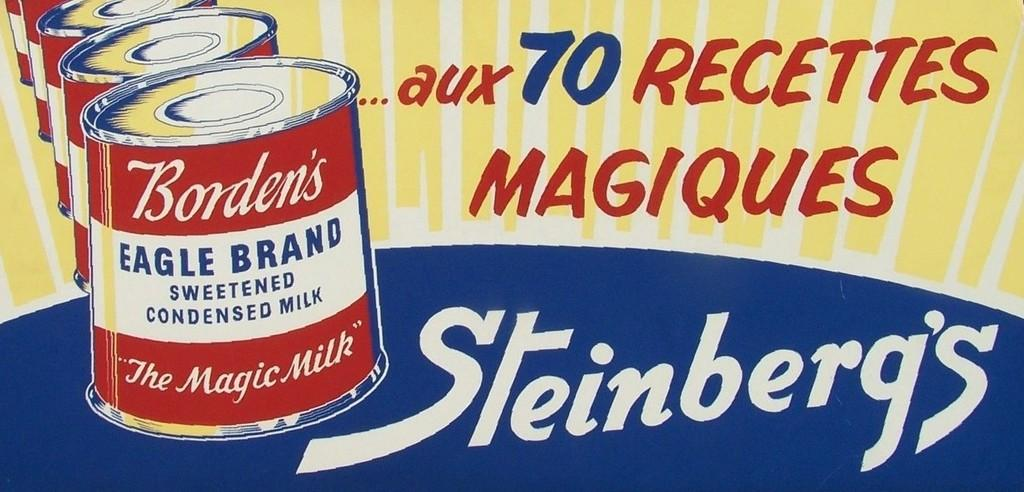<image>
Present a compact description of the photo's key features. An advertisement for Steinberg's which features sweetened condensed milk. 